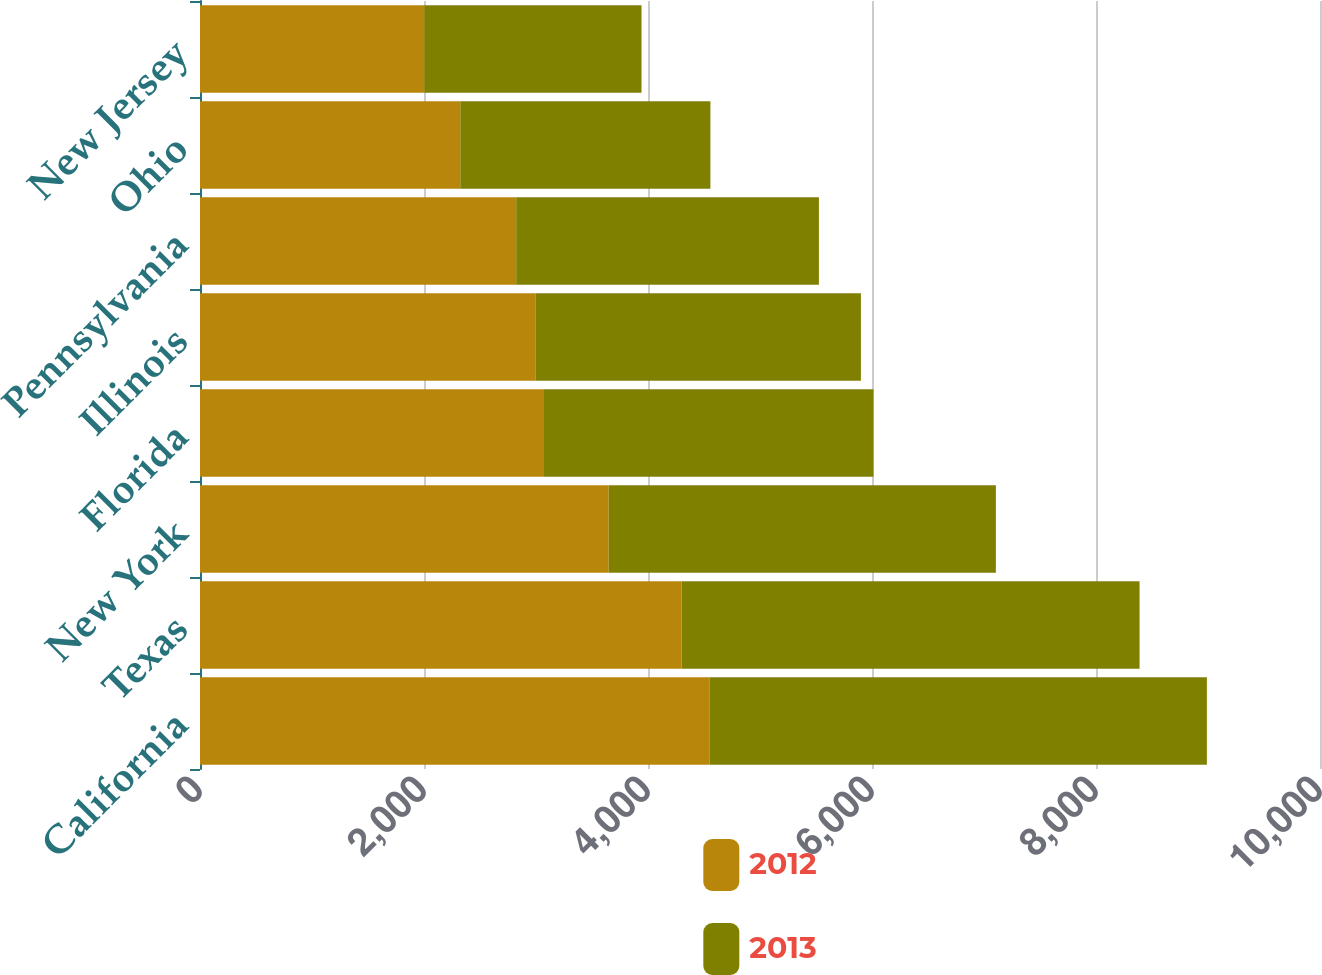Convert chart. <chart><loc_0><loc_0><loc_500><loc_500><stacked_bar_chart><ecel><fcel>California<fcel>Texas<fcel>New York<fcel>Florida<fcel>Illinois<fcel>Pennsylvania<fcel>Ohio<fcel>New Jersey<nl><fcel>2012<fcel>4548<fcel>4299<fcel>3649<fcel>3064<fcel>2998<fcel>2823<fcel>2324<fcel>2002<nl><fcel>2013<fcel>4442<fcel>4090<fcel>3457<fcel>2949<fcel>2903<fcel>2703<fcel>2233<fcel>1940<nl></chart> 